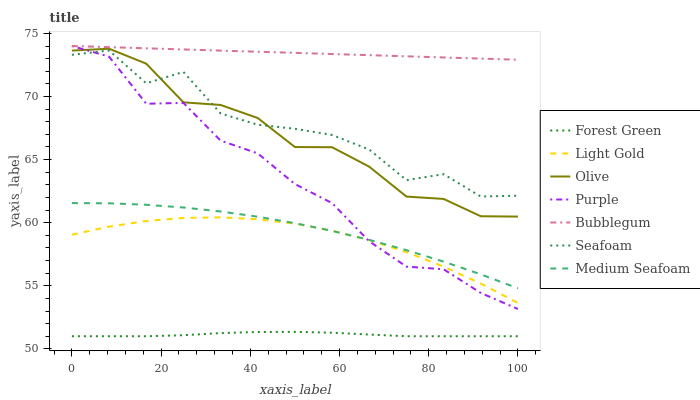Does Forest Green have the minimum area under the curve?
Answer yes or no. Yes. Does Bubblegum have the maximum area under the curve?
Answer yes or no. Yes. Does Seafoam have the minimum area under the curve?
Answer yes or no. No. Does Seafoam have the maximum area under the curve?
Answer yes or no. No. Is Bubblegum the smoothest?
Answer yes or no. Yes. Is Seafoam the roughest?
Answer yes or no. Yes. Is Seafoam the smoothest?
Answer yes or no. No. Is Bubblegum the roughest?
Answer yes or no. No. Does Forest Green have the lowest value?
Answer yes or no. Yes. Does Seafoam have the lowest value?
Answer yes or no. No. Does Bubblegum have the highest value?
Answer yes or no. Yes. Does Seafoam have the highest value?
Answer yes or no. No. Is Forest Green less than Olive?
Answer yes or no. Yes. Is Bubblegum greater than Forest Green?
Answer yes or no. Yes. Does Seafoam intersect Olive?
Answer yes or no. Yes. Is Seafoam less than Olive?
Answer yes or no. No. Is Seafoam greater than Olive?
Answer yes or no. No. Does Forest Green intersect Olive?
Answer yes or no. No. 